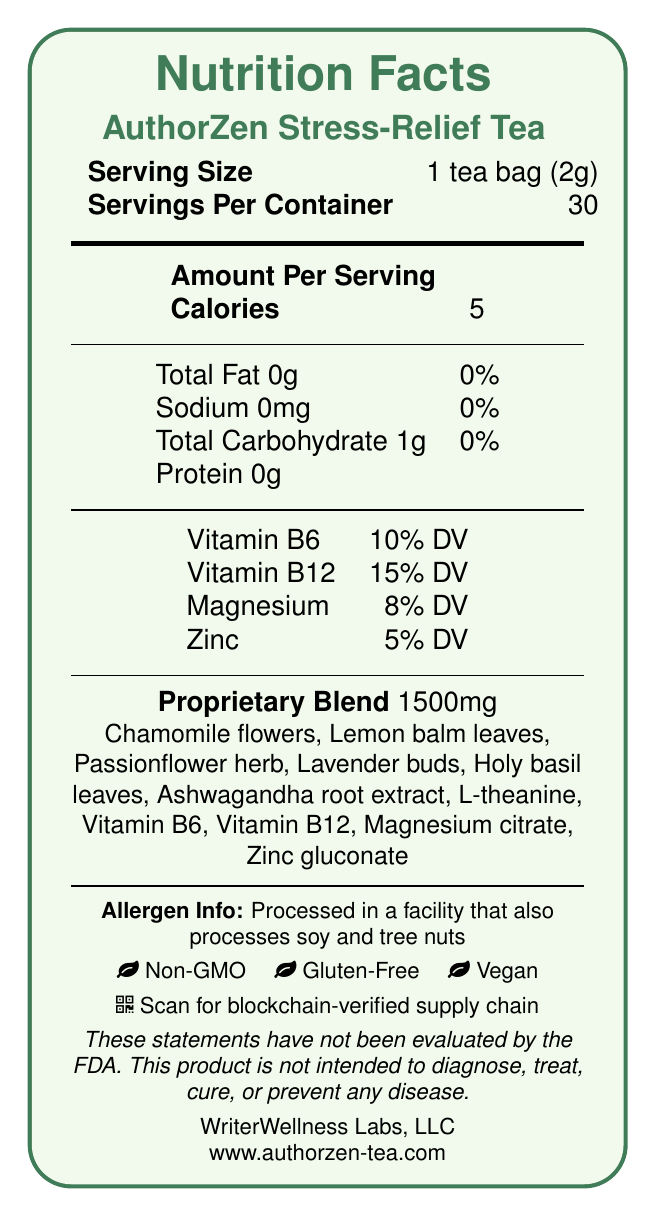What is the serving size of AuthorZen Stress-Relief Tea? According to the document, the serving size is listed as 1 tea bag (2g).
Answer: 1 tea bag (2g) How many calories are in one serving of AuthorZen Stress-Relief Tea? The document states that each serving contains 5 calories.
Answer: 5 List the vitamins and minerals included in AuthorZen Stress-Relief Tea along with their daily value percentages. The document provides the vitamins and minerals with their respective daily value percentages.
Answer: Vitamin B6: 10% DV, Vitamin B12: 15% DV, Magnesium: 8% DV, Zinc: 5% DV What proprietary blend quantity is included in each serving of the tea? The proprietary blend is listed as 1500mg.
Answer: 1500mg What are some of the primary ingredients in AuthorZen Stress-Relief Tea? The list of primary ingredients is provided in the document.
Answer: Chamomile flowers, Lemon balm leaves, Passionflower herb, Lavender buds, Holy basil leaves, Ashwagandha root extract, L-theanine, Vitamin B6, Vitamin B12, Magnesium citrate, Zinc gluconate How should AuthorZen Stress-Relief Tea be used? The document includes usage instructions, stating how to steep and consume the tea.
Answer: Steep one tea bag in 8 oz of hot water for 5-7 minutes. Enjoy 1-2 cups daily, especially during intense writing or editing sessions. Is AuthorZen Stress-Relief Tea processed in a facility that handles soy and tree nuts? The document states that it is processed in a facility that also processes soy and tree nuts.
Answer: Yes What environmentally friendly practices does AuthorZen Stress-Relief Tea employ? The sustainability information section outlines these practices.
Answer: Packaging made from 100% recycled materials. We plant one tree for every 100 boxes sold. Which company manufactures AuthorZen Stress-Relief Tea? The document lists WriterWellness Labs, LLC as the manufacturer.
Answer: WriterWellness Labs, LLC Does this product contain any artificial flavors or preservatives? The document claims that the product has "No artificial flavors or preservatives."
Answer: No What is the total carbohydrate content per serving of AuthorZen Stress-Relief Tea? A. 0g B. 1g C. 5g D. 10g The document lists the total carbohydrate content as 1g per serving.
Answer: B Which one of these claims is NOT true for the tea? A. Non-GMO B. Gluten-Free C. Contains artificial flavors D. Vegan The document lists the claims as Non-GMO, Gluten-Free, and Vegan, but it specifically notes that it does not contain artificial flavors.
Answer: C Does the document provide blockchain traceability information? The document mentions that each package contains a QR code linking to the tea's blockchain-verified supply chain and royalty distribution.
Answer: Yes Explain the main idea of the document. The summary explains all the major points covered in the nutrition facts label for the tea.
Answer: The document provides detailed nutrition facts and additional information about AuthorZen Stress-Relief Tea, such as serving size, ingredients, vitamin and mineral content, usage instructions, allergen information, claims (Non-GMO, Gluten-Free, Vegan), sustainability practices, and manufacturer details. The product is also supported by blockchain traceability. What is the exact magnesium source listed in the ingredients of the tea? The document specifies Magnesium citrate as the source of magnesium in the ingredients list.
Answer: Magnesium citrate What does the QR code on the package link to? The document mentions that the QR code links to the tea's blockchain-verified supply chain and royalty distribution.
Answer: Blockchain-verified supply chain and royalty distribution What is the daily value percentage of zinc in a serving of this tea? The document lists the daily value percentage of zinc as 5%.
Answer: 5% When is the tea best used by? The expiration date provided in the document states it is best if used within 18 months of production date.
Answer: Best if used within 18 months of production date What is the contact email for AuthorZen Tea support? The document lists the contact email as support@authorzen-tea.com.
Answer: support@authorzen-tea.com Can we determine the price of the tea from the document? The document does not provide any pricing information, hence it cannot be determined.
Answer: Not enough information 